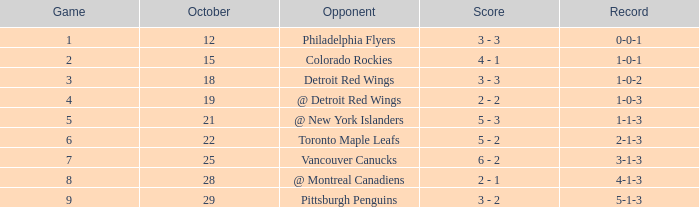Name the least game for october 21 5.0. 